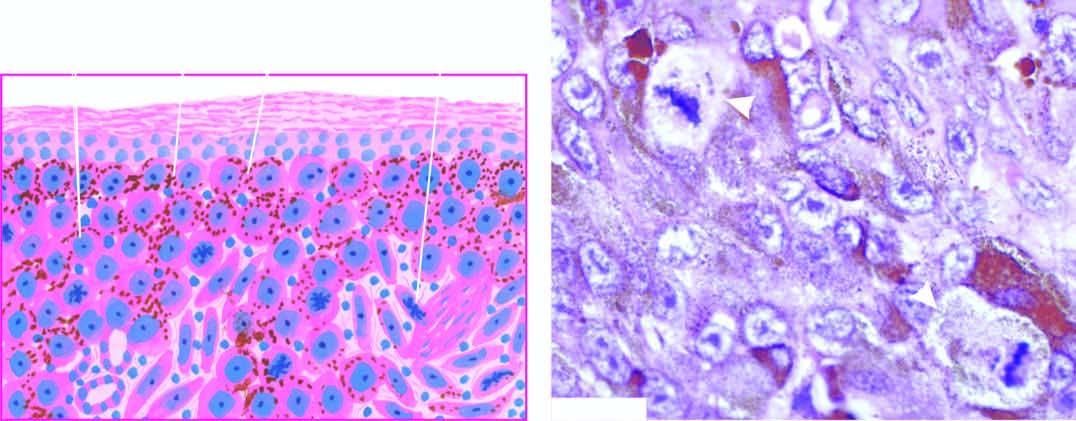does photomicrograph show a prominent atypical mitotic figure?
Answer the question using a single word or phrase. Yes 